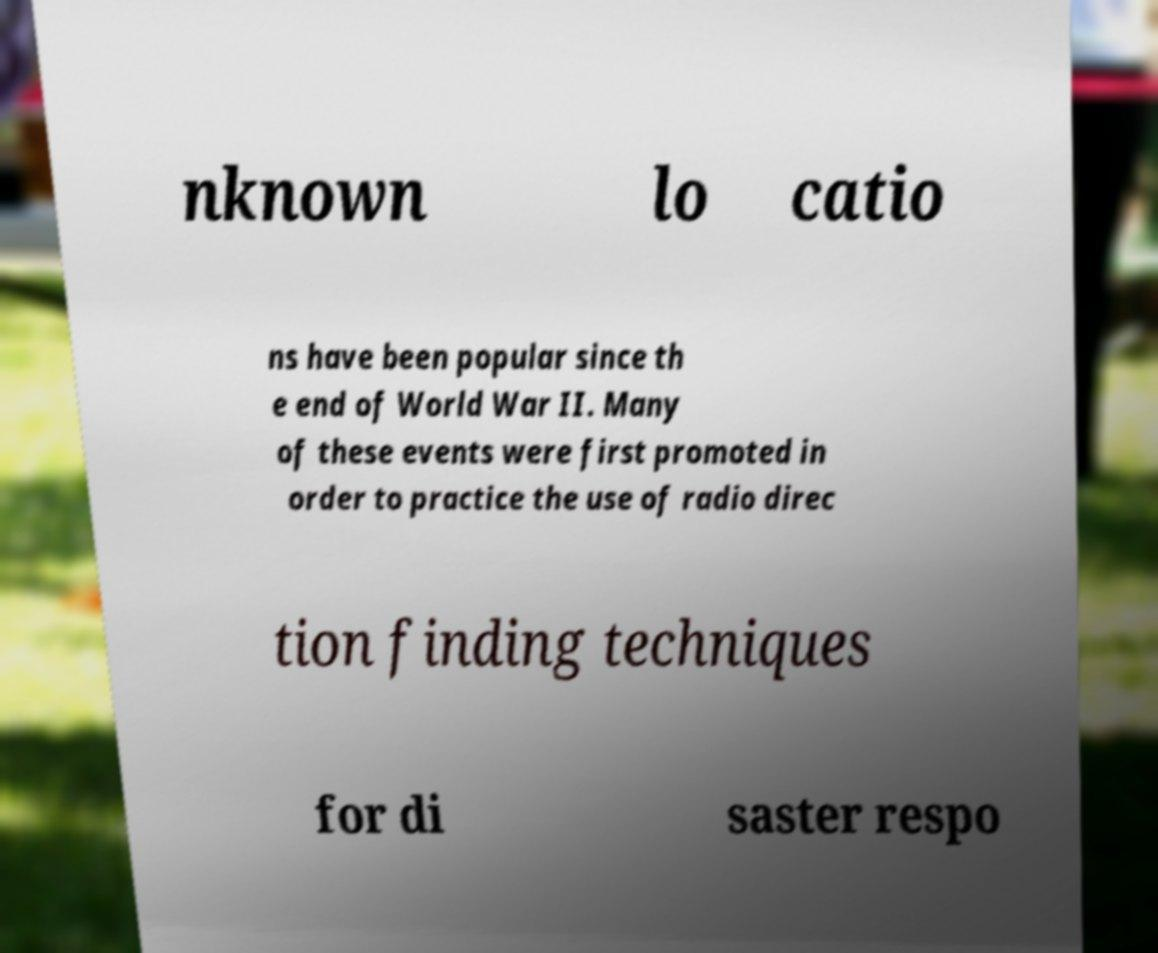I need the written content from this picture converted into text. Can you do that? nknown lo catio ns have been popular since th e end of World War II. Many of these events were first promoted in order to practice the use of radio direc tion finding techniques for di saster respo 